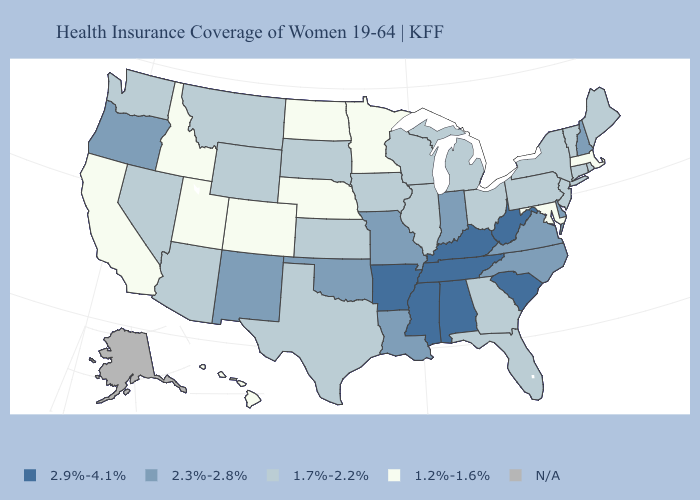Does Massachusetts have the lowest value in the Northeast?
Answer briefly. Yes. Among the states that border Vermont , which have the highest value?
Short answer required. New Hampshire. Among the states that border Georgia , which have the highest value?
Give a very brief answer. Alabama, South Carolina, Tennessee. What is the value of Wisconsin?
Be succinct. 1.7%-2.2%. Name the states that have a value in the range 2.3%-2.8%?
Keep it brief. Delaware, Indiana, Louisiana, Missouri, New Hampshire, New Mexico, North Carolina, Oklahoma, Oregon, Virginia. Does New York have the highest value in the USA?
Write a very short answer. No. Which states have the lowest value in the West?
Write a very short answer. California, Colorado, Hawaii, Idaho, Utah. Among the states that border Nevada , which have the highest value?
Keep it brief. Oregon. What is the value of California?
Concise answer only. 1.2%-1.6%. Name the states that have a value in the range 2.3%-2.8%?
Keep it brief. Delaware, Indiana, Louisiana, Missouri, New Hampshire, New Mexico, North Carolina, Oklahoma, Oregon, Virginia. Does the map have missing data?
Answer briefly. Yes. Is the legend a continuous bar?
Give a very brief answer. No. Among the states that border Rhode Island , does Connecticut have the lowest value?
Short answer required. No. Name the states that have a value in the range 1.2%-1.6%?
Quick response, please. California, Colorado, Hawaii, Idaho, Maryland, Massachusetts, Minnesota, Nebraska, North Dakota, Utah. 